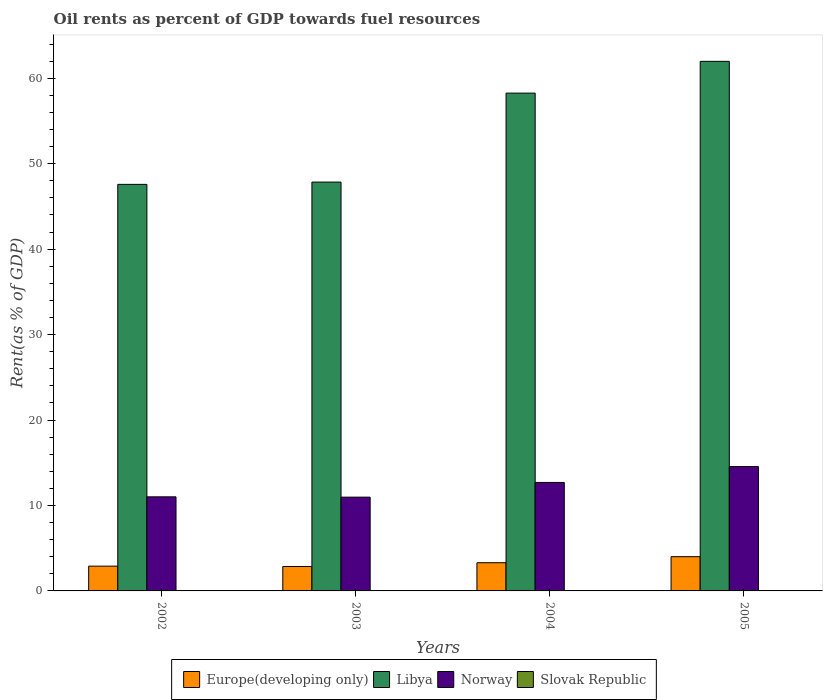Are the number of bars per tick equal to the number of legend labels?
Your answer should be very brief. Yes. Are the number of bars on each tick of the X-axis equal?
Ensure brevity in your answer.  Yes. How many bars are there on the 1st tick from the left?
Offer a terse response. 4. What is the label of the 1st group of bars from the left?
Your response must be concise. 2002. What is the oil rent in Slovak Republic in 2003?
Offer a very short reply. 0.01. Across all years, what is the maximum oil rent in Europe(developing only)?
Ensure brevity in your answer.  4.01. Across all years, what is the minimum oil rent in Europe(developing only)?
Your answer should be very brief. 2.86. What is the total oil rent in Norway in the graph?
Keep it short and to the point. 49.23. What is the difference between the oil rent in Libya in 2003 and that in 2005?
Your answer should be compact. -14.13. What is the difference between the oil rent in Norway in 2003 and the oil rent in Europe(developing only) in 2002?
Provide a succinct answer. 8.07. What is the average oil rent in Europe(developing only) per year?
Ensure brevity in your answer.  3.27. In the year 2005, what is the difference between the oil rent in Europe(developing only) and oil rent in Slovak Republic?
Provide a succinct answer. 3.99. What is the ratio of the oil rent in Libya in 2003 to that in 2005?
Offer a terse response. 0.77. What is the difference between the highest and the second highest oil rent in Norway?
Offer a very short reply. 1.85. What is the difference between the highest and the lowest oil rent in Libya?
Keep it short and to the point. 14.4. In how many years, is the oil rent in Norway greater than the average oil rent in Norway taken over all years?
Give a very brief answer. 2. Is it the case that in every year, the sum of the oil rent in Libya and oil rent in Europe(developing only) is greater than the sum of oil rent in Norway and oil rent in Slovak Republic?
Your response must be concise. Yes. What does the 2nd bar from the left in 2003 represents?
Ensure brevity in your answer.  Libya. What does the 2nd bar from the right in 2003 represents?
Offer a terse response. Norway. How many bars are there?
Offer a very short reply. 16. What is the difference between two consecutive major ticks on the Y-axis?
Offer a very short reply. 10. Are the values on the major ticks of Y-axis written in scientific E-notation?
Offer a terse response. No. How are the legend labels stacked?
Your answer should be very brief. Horizontal. What is the title of the graph?
Provide a succinct answer. Oil rents as percent of GDP towards fuel resources. Does "Sri Lanka" appear as one of the legend labels in the graph?
Offer a very short reply. No. What is the label or title of the Y-axis?
Provide a succinct answer. Rent(as % of GDP). What is the Rent(as % of GDP) of Europe(developing only) in 2002?
Offer a terse response. 2.9. What is the Rent(as % of GDP) of Libya in 2002?
Make the answer very short. 47.58. What is the Rent(as % of GDP) of Norway in 2002?
Keep it short and to the point. 11.01. What is the Rent(as % of GDP) in Slovak Republic in 2002?
Your answer should be compact. 0.02. What is the Rent(as % of GDP) of Europe(developing only) in 2003?
Ensure brevity in your answer.  2.86. What is the Rent(as % of GDP) in Libya in 2003?
Keep it short and to the point. 47.85. What is the Rent(as % of GDP) in Norway in 2003?
Give a very brief answer. 10.97. What is the Rent(as % of GDP) in Slovak Republic in 2003?
Make the answer very short. 0.01. What is the Rent(as % of GDP) in Europe(developing only) in 2004?
Your answer should be very brief. 3.3. What is the Rent(as % of GDP) of Libya in 2004?
Make the answer very short. 58.26. What is the Rent(as % of GDP) in Norway in 2004?
Your answer should be very brief. 12.69. What is the Rent(as % of GDP) in Slovak Republic in 2004?
Provide a succinct answer. 0.02. What is the Rent(as % of GDP) of Europe(developing only) in 2005?
Your response must be concise. 4.01. What is the Rent(as % of GDP) in Libya in 2005?
Give a very brief answer. 61.97. What is the Rent(as % of GDP) in Norway in 2005?
Make the answer very short. 14.55. What is the Rent(as % of GDP) in Slovak Republic in 2005?
Your response must be concise. 0.02. Across all years, what is the maximum Rent(as % of GDP) of Europe(developing only)?
Give a very brief answer. 4.01. Across all years, what is the maximum Rent(as % of GDP) in Libya?
Your response must be concise. 61.97. Across all years, what is the maximum Rent(as % of GDP) in Norway?
Make the answer very short. 14.55. Across all years, what is the maximum Rent(as % of GDP) of Slovak Republic?
Provide a short and direct response. 0.02. Across all years, what is the minimum Rent(as % of GDP) of Europe(developing only)?
Your response must be concise. 2.86. Across all years, what is the minimum Rent(as % of GDP) of Libya?
Your response must be concise. 47.58. Across all years, what is the minimum Rent(as % of GDP) of Norway?
Provide a succinct answer. 10.97. Across all years, what is the minimum Rent(as % of GDP) of Slovak Republic?
Ensure brevity in your answer.  0.01. What is the total Rent(as % of GDP) in Europe(developing only) in the graph?
Provide a succinct answer. 13.07. What is the total Rent(as % of GDP) in Libya in the graph?
Offer a terse response. 215.66. What is the total Rent(as % of GDP) of Norway in the graph?
Provide a short and direct response. 49.23. What is the total Rent(as % of GDP) in Slovak Republic in the graph?
Offer a very short reply. 0.06. What is the difference between the Rent(as % of GDP) in Europe(developing only) in 2002 and that in 2003?
Provide a short and direct response. 0.04. What is the difference between the Rent(as % of GDP) in Libya in 2002 and that in 2003?
Give a very brief answer. -0.27. What is the difference between the Rent(as % of GDP) of Norway in 2002 and that in 2003?
Keep it short and to the point. 0.04. What is the difference between the Rent(as % of GDP) in Slovak Republic in 2002 and that in 2003?
Make the answer very short. 0. What is the difference between the Rent(as % of GDP) in Europe(developing only) in 2002 and that in 2004?
Ensure brevity in your answer.  -0.4. What is the difference between the Rent(as % of GDP) in Libya in 2002 and that in 2004?
Your answer should be compact. -10.68. What is the difference between the Rent(as % of GDP) of Norway in 2002 and that in 2004?
Your answer should be very brief. -1.68. What is the difference between the Rent(as % of GDP) of Slovak Republic in 2002 and that in 2004?
Give a very brief answer. 0. What is the difference between the Rent(as % of GDP) in Europe(developing only) in 2002 and that in 2005?
Your response must be concise. -1.11. What is the difference between the Rent(as % of GDP) of Libya in 2002 and that in 2005?
Make the answer very short. -14.4. What is the difference between the Rent(as % of GDP) in Norway in 2002 and that in 2005?
Provide a short and direct response. -3.54. What is the difference between the Rent(as % of GDP) of Slovak Republic in 2002 and that in 2005?
Your answer should be compact. 0. What is the difference between the Rent(as % of GDP) in Europe(developing only) in 2003 and that in 2004?
Provide a succinct answer. -0.44. What is the difference between the Rent(as % of GDP) of Libya in 2003 and that in 2004?
Offer a terse response. -10.41. What is the difference between the Rent(as % of GDP) of Norway in 2003 and that in 2004?
Your answer should be compact. -1.72. What is the difference between the Rent(as % of GDP) in Slovak Republic in 2003 and that in 2004?
Provide a short and direct response. -0. What is the difference between the Rent(as % of GDP) in Europe(developing only) in 2003 and that in 2005?
Offer a terse response. -1.15. What is the difference between the Rent(as % of GDP) in Libya in 2003 and that in 2005?
Give a very brief answer. -14.13. What is the difference between the Rent(as % of GDP) of Norway in 2003 and that in 2005?
Offer a terse response. -3.57. What is the difference between the Rent(as % of GDP) in Slovak Republic in 2003 and that in 2005?
Your answer should be very brief. -0. What is the difference between the Rent(as % of GDP) in Europe(developing only) in 2004 and that in 2005?
Your answer should be very brief. -0.71. What is the difference between the Rent(as % of GDP) of Libya in 2004 and that in 2005?
Provide a short and direct response. -3.72. What is the difference between the Rent(as % of GDP) of Norway in 2004 and that in 2005?
Offer a very short reply. -1.85. What is the difference between the Rent(as % of GDP) in Slovak Republic in 2004 and that in 2005?
Offer a terse response. -0. What is the difference between the Rent(as % of GDP) in Europe(developing only) in 2002 and the Rent(as % of GDP) in Libya in 2003?
Offer a terse response. -44.95. What is the difference between the Rent(as % of GDP) in Europe(developing only) in 2002 and the Rent(as % of GDP) in Norway in 2003?
Ensure brevity in your answer.  -8.07. What is the difference between the Rent(as % of GDP) in Europe(developing only) in 2002 and the Rent(as % of GDP) in Slovak Republic in 2003?
Your answer should be very brief. 2.89. What is the difference between the Rent(as % of GDP) in Libya in 2002 and the Rent(as % of GDP) in Norway in 2003?
Your response must be concise. 36.6. What is the difference between the Rent(as % of GDP) in Libya in 2002 and the Rent(as % of GDP) in Slovak Republic in 2003?
Make the answer very short. 47.56. What is the difference between the Rent(as % of GDP) of Norway in 2002 and the Rent(as % of GDP) of Slovak Republic in 2003?
Your answer should be compact. 11. What is the difference between the Rent(as % of GDP) of Europe(developing only) in 2002 and the Rent(as % of GDP) of Libya in 2004?
Your answer should be compact. -55.36. What is the difference between the Rent(as % of GDP) in Europe(developing only) in 2002 and the Rent(as % of GDP) in Norway in 2004?
Offer a very short reply. -9.79. What is the difference between the Rent(as % of GDP) of Europe(developing only) in 2002 and the Rent(as % of GDP) of Slovak Republic in 2004?
Make the answer very short. 2.89. What is the difference between the Rent(as % of GDP) in Libya in 2002 and the Rent(as % of GDP) in Norway in 2004?
Keep it short and to the point. 34.88. What is the difference between the Rent(as % of GDP) in Libya in 2002 and the Rent(as % of GDP) in Slovak Republic in 2004?
Offer a terse response. 47.56. What is the difference between the Rent(as % of GDP) of Norway in 2002 and the Rent(as % of GDP) of Slovak Republic in 2004?
Make the answer very short. 11. What is the difference between the Rent(as % of GDP) of Europe(developing only) in 2002 and the Rent(as % of GDP) of Libya in 2005?
Offer a terse response. -59.07. What is the difference between the Rent(as % of GDP) of Europe(developing only) in 2002 and the Rent(as % of GDP) of Norway in 2005?
Offer a terse response. -11.65. What is the difference between the Rent(as % of GDP) of Europe(developing only) in 2002 and the Rent(as % of GDP) of Slovak Republic in 2005?
Offer a terse response. 2.88. What is the difference between the Rent(as % of GDP) in Libya in 2002 and the Rent(as % of GDP) in Norway in 2005?
Keep it short and to the point. 33.03. What is the difference between the Rent(as % of GDP) of Libya in 2002 and the Rent(as % of GDP) of Slovak Republic in 2005?
Provide a succinct answer. 47.56. What is the difference between the Rent(as % of GDP) of Norway in 2002 and the Rent(as % of GDP) of Slovak Republic in 2005?
Offer a very short reply. 10.99. What is the difference between the Rent(as % of GDP) in Europe(developing only) in 2003 and the Rent(as % of GDP) in Libya in 2004?
Offer a terse response. -55.4. What is the difference between the Rent(as % of GDP) of Europe(developing only) in 2003 and the Rent(as % of GDP) of Norway in 2004?
Provide a short and direct response. -9.84. What is the difference between the Rent(as % of GDP) in Europe(developing only) in 2003 and the Rent(as % of GDP) in Slovak Republic in 2004?
Keep it short and to the point. 2.84. What is the difference between the Rent(as % of GDP) in Libya in 2003 and the Rent(as % of GDP) in Norway in 2004?
Keep it short and to the point. 35.15. What is the difference between the Rent(as % of GDP) in Libya in 2003 and the Rent(as % of GDP) in Slovak Republic in 2004?
Your response must be concise. 47.83. What is the difference between the Rent(as % of GDP) of Norway in 2003 and the Rent(as % of GDP) of Slovak Republic in 2004?
Your answer should be very brief. 10.96. What is the difference between the Rent(as % of GDP) of Europe(developing only) in 2003 and the Rent(as % of GDP) of Libya in 2005?
Make the answer very short. -59.12. What is the difference between the Rent(as % of GDP) in Europe(developing only) in 2003 and the Rent(as % of GDP) in Norway in 2005?
Give a very brief answer. -11.69. What is the difference between the Rent(as % of GDP) in Europe(developing only) in 2003 and the Rent(as % of GDP) in Slovak Republic in 2005?
Give a very brief answer. 2.84. What is the difference between the Rent(as % of GDP) of Libya in 2003 and the Rent(as % of GDP) of Norway in 2005?
Ensure brevity in your answer.  33.3. What is the difference between the Rent(as % of GDP) in Libya in 2003 and the Rent(as % of GDP) in Slovak Republic in 2005?
Give a very brief answer. 47.83. What is the difference between the Rent(as % of GDP) of Norway in 2003 and the Rent(as % of GDP) of Slovak Republic in 2005?
Provide a succinct answer. 10.96. What is the difference between the Rent(as % of GDP) in Europe(developing only) in 2004 and the Rent(as % of GDP) in Libya in 2005?
Offer a terse response. -58.68. What is the difference between the Rent(as % of GDP) in Europe(developing only) in 2004 and the Rent(as % of GDP) in Norway in 2005?
Offer a very short reply. -11.25. What is the difference between the Rent(as % of GDP) in Europe(developing only) in 2004 and the Rent(as % of GDP) in Slovak Republic in 2005?
Your response must be concise. 3.28. What is the difference between the Rent(as % of GDP) in Libya in 2004 and the Rent(as % of GDP) in Norway in 2005?
Your answer should be very brief. 43.71. What is the difference between the Rent(as % of GDP) of Libya in 2004 and the Rent(as % of GDP) of Slovak Republic in 2005?
Your answer should be compact. 58.24. What is the difference between the Rent(as % of GDP) in Norway in 2004 and the Rent(as % of GDP) in Slovak Republic in 2005?
Your answer should be compact. 12.68. What is the average Rent(as % of GDP) of Europe(developing only) per year?
Your response must be concise. 3.27. What is the average Rent(as % of GDP) in Libya per year?
Provide a short and direct response. 53.91. What is the average Rent(as % of GDP) in Norway per year?
Your answer should be compact. 12.31. What is the average Rent(as % of GDP) of Slovak Republic per year?
Offer a very short reply. 0.02. In the year 2002, what is the difference between the Rent(as % of GDP) of Europe(developing only) and Rent(as % of GDP) of Libya?
Offer a very short reply. -44.68. In the year 2002, what is the difference between the Rent(as % of GDP) of Europe(developing only) and Rent(as % of GDP) of Norway?
Offer a very short reply. -8.11. In the year 2002, what is the difference between the Rent(as % of GDP) of Europe(developing only) and Rent(as % of GDP) of Slovak Republic?
Your answer should be very brief. 2.88. In the year 2002, what is the difference between the Rent(as % of GDP) in Libya and Rent(as % of GDP) in Norway?
Keep it short and to the point. 36.57. In the year 2002, what is the difference between the Rent(as % of GDP) in Libya and Rent(as % of GDP) in Slovak Republic?
Offer a very short reply. 47.56. In the year 2002, what is the difference between the Rent(as % of GDP) of Norway and Rent(as % of GDP) of Slovak Republic?
Your answer should be very brief. 10.99. In the year 2003, what is the difference between the Rent(as % of GDP) of Europe(developing only) and Rent(as % of GDP) of Libya?
Keep it short and to the point. -44.99. In the year 2003, what is the difference between the Rent(as % of GDP) of Europe(developing only) and Rent(as % of GDP) of Norway?
Offer a terse response. -8.12. In the year 2003, what is the difference between the Rent(as % of GDP) in Europe(developing only) and Rent(as % of GDP) in Slovak Republic?
Make the answer very short. 2.84. In the year 2003, what is the difference between the Rent(as % of GDP) of Libya and Rent(as % of GDP) of Norway?
Ensure brevity in your answer.  36.87. In the year 2003, what is the difference between the Rent(as % of GDP) in Libya and Rent(as % of GDP) in Slovak Republic?
Your response must be concise. 47.83. In the year 2003, what is the difference between the Rent(as % of GDP) in Norway and Rent(as % of GDP) in Slovak Republic?
Your answer should be compact. 10.96. In the year 2004, what is the difference between the Rent(as % of GDP) in Europe(developing only) and Rent(as % of GDP) in Libya?
Your answer should be compact. -54.96. In the year 2004, what is the difference between the Rent(as % of GDP) of Europe(developing only) and Rent(as % of GDP) of Norway?
Your answer should be compact. -9.39. In the year 2004, what is the difference between the Rent(as % of GDP) in Europe(developing only) and Rent(as % of GDP) in Slovak Republic?
Provide a short and direct response. 3.28. In the year 2004, what is the difference between the Rent(as % of GDP) in Libya and Rent(as % of GDP) in Norway?
Your answer should be very brief. 45.56. In the year 2004, what is the difference between the Rent(as % of GDP) of Libya and Rent(as % of GDP) of Slovak Republic?
Provide a short and direct response. 58.24. In the year 2004, what is the difference between the Rent(as % of GDP) in Norway and Rent(as % of GDP) in Slovak Republic?
Offer a very short reply. 12.68. In the year 2005, what is the difference between the Rent(as % of GDP) in Europe(developing only) and Rent(as % of GDP) in Libya?
Give a very brief answer. -57.97. In the year 2005, what is the difference between the Rent(as % of GDP) in Europe(developing only) and Rent(as % of GDP) in Norway?
Keep it short and to the point. -10.54. In the year 2005, what is the difference between the Rent(as % of GDP) of Europe(developing only) and Rent(as % of GDP) of Slovak Republic?
Your answer should be very brief. 3.99. In the year 2005, what is the difference between the Rent(as % of GDP) in Libya and Rent(as % of GDP) in Norway?
Give a very brief answer. 47.43. In the year 2005, what is the difference between the Rent(as % of GDP) of Libya and Rent(as % of GDP) of Slovak Republic?
Make the answer very short. 61.96. In the year 2005, what is the difference between the Rent(as % of GDP) of Norway and Rent(as % of GDP) of Slovak Republic?
Offer a terse response. 14.53. What is the ratio of the Rent(as % of GDP) of Europe(developing only) in 2002 to that in 2003?
Ensure brevity in your answer.  1.01. What is the ratio of the Rent(as % of GDP) of Norway in 2002 to that in 2003?
Provide a succinct answer. 1. What is the ratio of the Rent(as % of GDP) of Slovak Republic in 2002 to that in 2003?
Make the answer very short. 1.16. What is the ratio of the Rent(as % of GDP) in Europe(developing only) in 2002 to that in 2004?
Ensure brevity in your answer.  0.88. What is the ratio of the Rent(as % of GDP) of Libya in 2002 to that in 2004?
Your answer should be very brief. 0.82. What is the ratio of the Rent(as % of GDP) in Norway in 2002 to that in 2004?
Ensure brevity in your answer.  0.87. What is the ratio of the Rent(as % of GDP) of Slovak Republic in 2002 to that in 2004?
Make the answer very short. 1.15. What is the ratio of the Rent(as % of GDP) of Europe(developing only) in 2002 to that in 2005?
Keep it short and to the point. 0.72. What is the ratio of the Rent(as % of GDP) of Libya in 2002 to that in 2005?
Provide a short and direct response. 0.77. What is the ratio of the Rent(as % of GDP) in Norway in 2002 to that in 2005?
Ensure brevity in your answer.  0.76. What is the ratio of the Rent(as % of GDP) of Slovak Republic in 2002 to that in 2005?
Provide a succinct answer. 1.05. What is the ratio of the Rent(as % of GDP) of Europe(developing only) in 2003 to that in 2004?
Provide a succinct answer. 0.87. What is the ratio of the Rent(as % of GDP) of Libya in 2003 to that in 2004?
Give a very brief answer. 0.82. What is the ratio of the Rent(as % of GDP) of Norway in 2003 to that in 2004?
Your response must be concise. 0.86. What is the ratio of the Rent(as % of GDP) of Slovak Republic in 2003 to that in 2004?
Keep it short and to the point. 0.99. What is the ratio of the Rent(as % of GDP) of Europe(developing only) in 2003 to that in 2005?
Keep it short and to the point. 0.71. What is the ratio of the Rent(as % of GDP) of Libya in 2003 to that in 2005?
Keep it short and to the point. 0.77. What is the ratio of the Rent(as % of GDP) of Norway in 2003 to that in 2005?
Give a very brief answer. 0.75. What is the ratio of the Rent(as % of GDP) of Slovak Republic in 2003 to that in 2005?
Keep it short and to the point. 0.9. What is the ratio of the Rent(as % of GDP) of Europe(developing only) in 2004 to that in 2005?
Offer a very short reply. 0.82. What is the ratio of the Rent(as % of GDP) of Norway in 2004 to that in 2005?
Offer a terse response. 0.87. What is the ratio of the Rent(as % of GDP) of Slovak Republic in 2004 to that in 2005?
Offer a very short reply. 0.91. What is the difference between the highest and the second highest Rent(as % of GDP) in Europe(developing only)?
Give a very brief answer. 0.71. What is the difference between the highest and the second highest Rent(as % of GDP) of Libya?
Provide a short and direct response. 3.72. What is the difference between the highest and the second highest Rent(as % of GDP) in Norway?
Provide a short and direct response. 1.85. What is the difference between the highest and the second highest Rent(as % of GDP) in Slovak Republic?
Your answer should be compact. 0. What is the difference between the highest and the lowest Rent(as % of GDP) of Europe(developing only)?
Ensure brevity in your answer.  1.15. What is the difference between the highest and the lowest Rent(as % of GDP) in Libya?
Give a very brief answer. 14.4. What is the difference between the highest and the lowest Rent(as % of GDP) of Norway?
Provide a succinct answer. 3.57. What is the difference between the highest and the lowest Rent(as % of GDP) of Slovak Republic?
Ensure brevity in your answer.  0. 